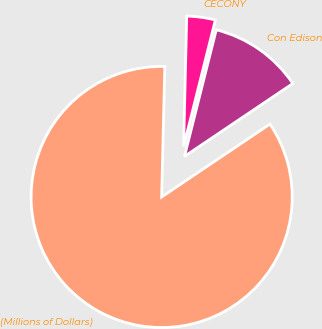Convert chart to OTSL. <chart><loc_0><loc_0><loc_500><loc_500><pie_chart><fcel>(Millions of Dollars)<fcel>Con Edison<fcel>CECONY<nl><fcel>84.81%<fcel>11.66%<fcel>3.53%<nl></chart> 